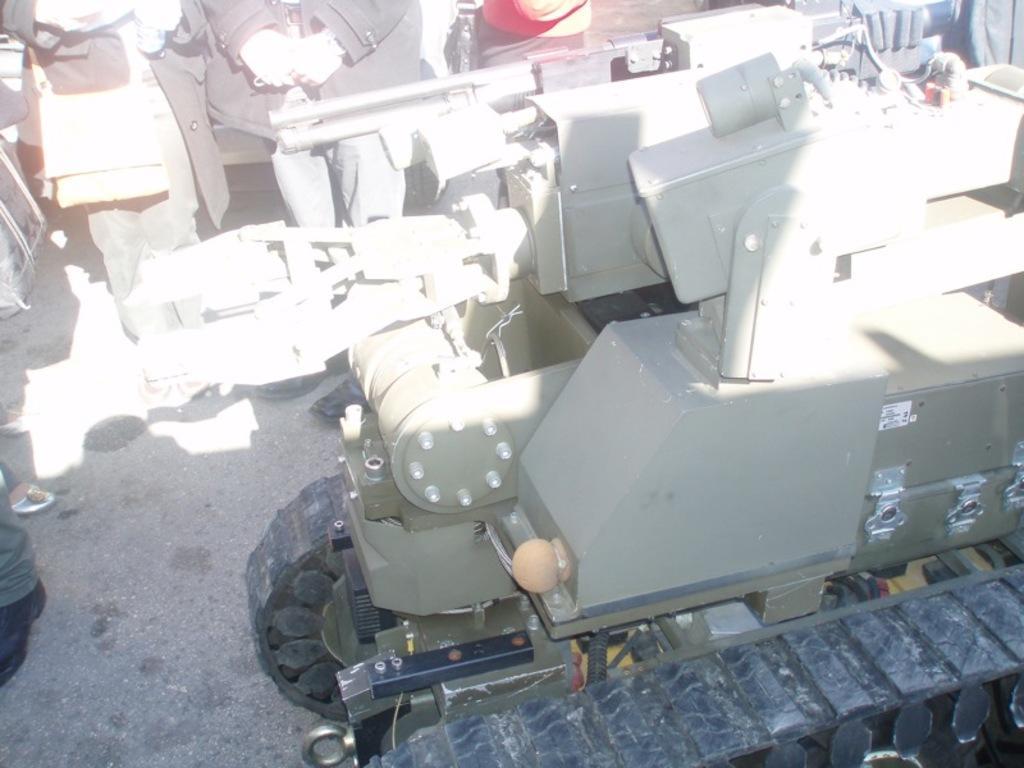In one or two sentences, can you explain what this image depicts? In this image I can see a vehicle in green and black color. Back I can see few people standing. 